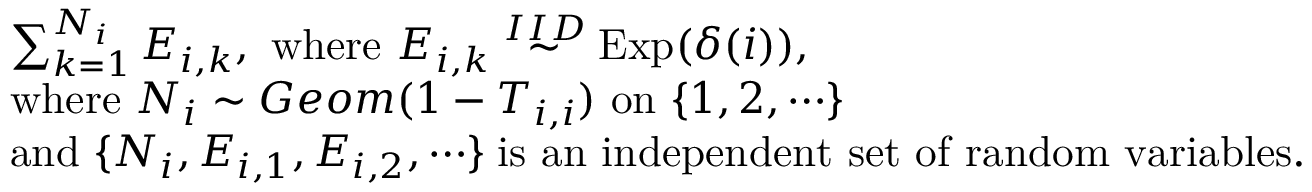<formula> <loc_0><loc_0><loc_500><loc_500>\begin{array} { r l } & { \sum _ { k = 1 } ^ { N _ { i } } E _ { i , k } , w h e r e E _ { i , k } \stackrel { I I D } { \sim } E x p ( \delta ( i ) ) , } \\ { \, } & { w h e r e N _ { i } \sim G e o m ( 1 - T _ { i , i } ) o n \{ 1 , 2 , \cdots \} } \\ & { a n d \{ N _ { i } , E _ { i , 1 } , E _ { i , 2 } , \cdots \} \, i s a n i n d e p e n d e n t s e t o f r a n d o m v a r i a b l e s . } \end{array}</formula> 